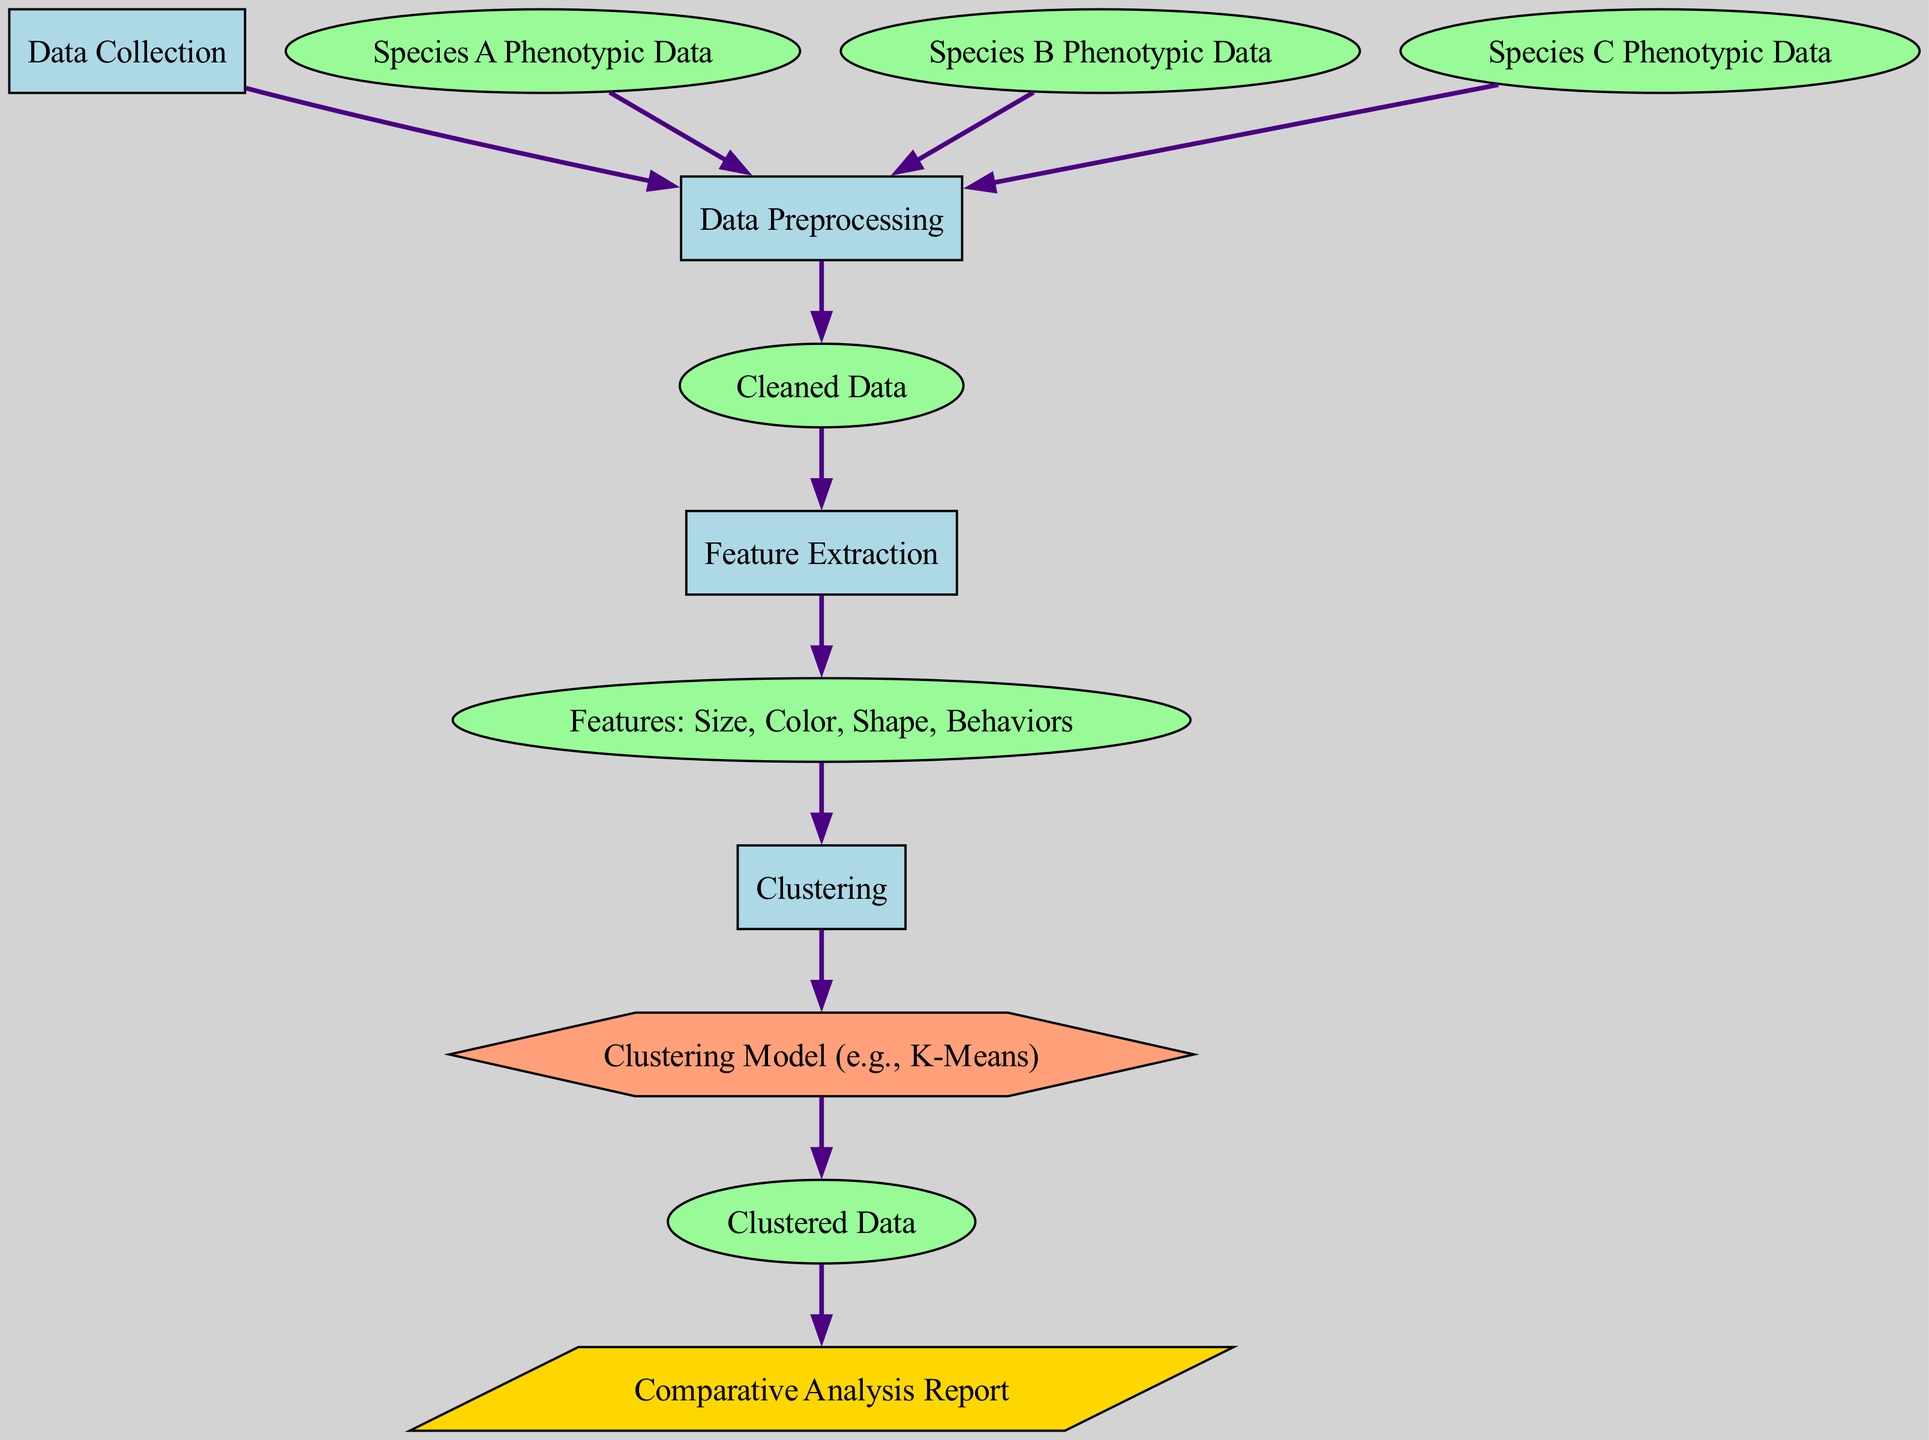What is the first process in the diagram? The diagram identifies "Data Collection" as the first process, as it is the initial node before any other processes occur.
Answer: Data Collection How many species' phenotypic data are included? The diagram shows three species: Species A, Species B, and Species C, each represented in separate nodes.
Answer: Three What is the type of the "Cleaned Data" node? The "Cleaned Data" node is categorized as data, based on its labeling in the diagram.
Answer: Data Which model is used for clustering in this analysis? The diagram specifies that a "Clustering Model (e.g., K-Means)" is used, indicated in the model node.
Answer: Clustering Model (e.g., K-Means) What nodes are connected to "Clustering"? The "Clustering" node is connected to the "Features: Size, Color, Shape, Behaviors" node as an input and leads to the "Clustering Model (e.g., K-Means)" node as the main output.
Answer: Features: Size, Color, Shape, Behaviors and Clustering Model (e.g., K-Means) What is the final output of the diagram? The final output is represented as "Comparative Analysis Report," indicating the end result of the entire process flow.
Answer: Comparative Analysis Report How does "Data Preprocessing" relate to "Data Collection"? "Data Preprocessing" directly follows "Data Collection" in the diagram, indicating that preprocessed data is derived from the collected data.
Answer: Sequentially dependent How many edges are present in the diagram? By counting the connections between the nodes in the diagram, there are a total of 11 edges illustrated.
Answer: Eleven Which type of node is "Features: Size, Color, Shape, Behaviors"? The "Features: Size, Color, Shape, Behaviors" node is classified as data, according to the type defined in the diagram.
Answer: Data 